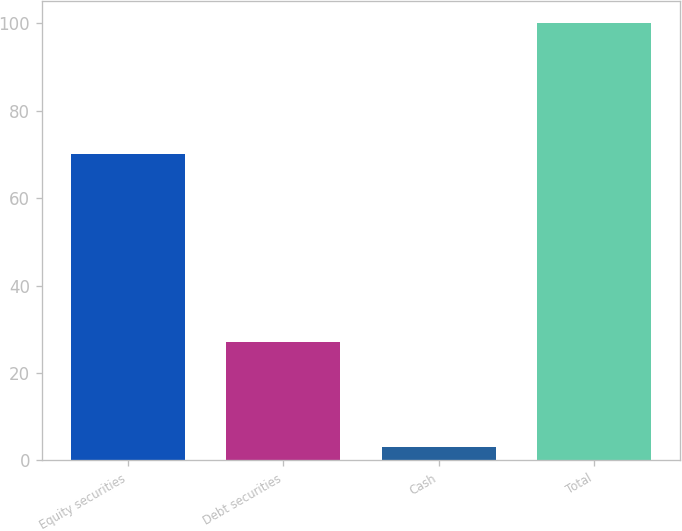Convert chart to OTSL. <chart><loc_0><loc_0><loc_500><loc_500><bar_chart><fcel>Equity securities<fcel>Debt securities<fcel>Cash<fcel>Total<nl><fcel>70<fcel>27<fcel>3<fcel>100<nl></chart> 